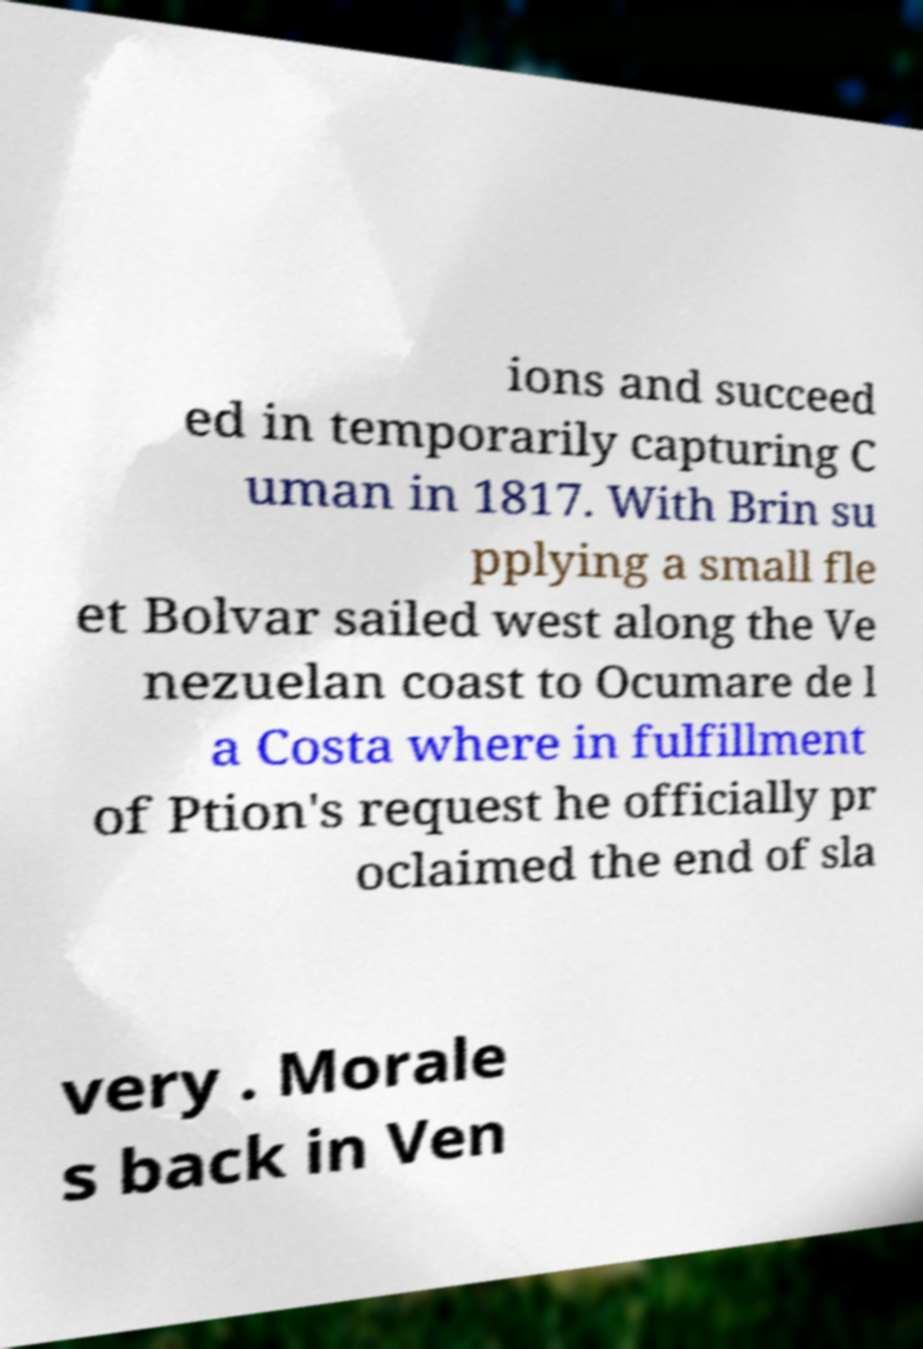Could you assist in decoding the text presented in this image and type it out clearly? ions and succeed ed in temporarily capturing C uman in 1817. With Brin su pplying a small fle et Bolvar sailed west along the Ve nezuelan coast to Ocumare de l a Costa where in fulfillment of Ption's request he officially pr oclaimed the end of sla very . Morale s back in Ven 